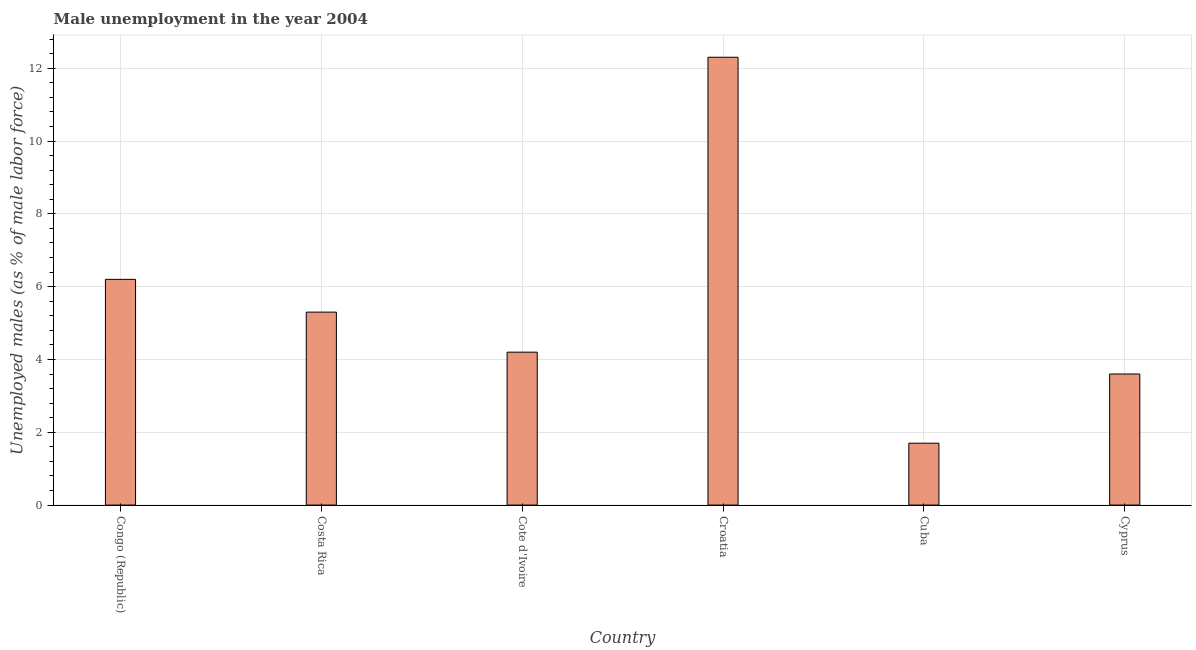Does the graph contain any zero values?
Your answer should be compact. No. Does the graph contain grids?
Provide a succinct answer. Yes. What is the title of the graph?
Offer a very short reply. Male unemployment in the year 2004. What is the label or title of the X-axis?
Give a very brief answer. Country. What is the label or title of the Y-axis?
Keep it short and to the point. Unemployed males (as % of male labor force). What is the unemployed males population in Congo (Republic)?
Your response must be concise. 6.2. Across all countries, what is the maximum unemployed males population?
Your answer should be very brief. 12.3. Across all countries, what is the minimum unemployed males population?
Offer a terse response. 1.7. In which country was the unemployed males population maximum?
Offer a very short reply. Croatia. In which country was the unemployed males population minimum?
Offer a terse response. Cuba. What is the sum of the unemployed males population?
Offer a terse response. 33.3. What is the difference between the unemployed males population in Cote d'Ivoire and Cyprus?
Provide a succinct answer. 0.6. What is the average unemployed males population per country?
Your response must be concise. 5.55. What is the median unemployed males population?
Offer a terse response. 4.75. What is the ratio of the unemployed males population in Cote d'Ivoire to that in Cuba?
Provide a succinct answer. 2.47. Is the unemployed males population in Cuba less than that in Cyprus?
Provide a short and direct response. Yes. Is the sum of the unemployed males population in Costa Rica and Croatia greater than the maximum unemployed males population across all countries?
Give a very brief answer. Yes. What is the difference between the highest and the lowest unemployed males population?
Make the answer very short. 10.6. In how many countries, is the unemployed males population greater than the average unemployed males population taken over all countries?
Make the answer very short. 2. Are all the bars in the graph horizontal?
Provide a succinct answer. No. How many countries are there in the graph?
Offer a very short reply. 6. What is the difference between two consecutive major ticks on the Y-axis?
Offer a very short reply. 2. Are the values on the major ticks of Y-axis written in scientific E-notation?
Keep it short and to the point. No. What is the Unemployed males (as % of male labor force) in Congo (Republic)?
Your answer should be very brief. 6.2. What is the Unemployed males (as % of male labor force) in Costa Rica?
Your response must be concise. 5.3. What is the Unemployed males (as % of male labor force) of Cote d'Ivoire?
Offer a terse response. 4.2. What is the Unemployed males (as % of male labor force) of Croatia?
Provide a short and direct response. 12.3. What is the Unemployed males (as % of male labor force) of Cuba?
Your answer should be very brief. 1.7. What is the Unemployed males (as % of male labor force) in Cyprus?
Make the answer very short. 3.6. What is the difference between the Unemployed males (as % of male labor force) in Congo (Republic) and Costa Rica?
Provide a succinct answer. 0.9. What is the difference between the Unemployed males (as % of male labor force) in Congo (Republic) and Cote d'Ivoire?
Provide a short and direct response. 2. What is the difference between the Unemployed males (as % of male labor force) in Costa Rica and Cyprus?
Your response must be concise. 1.7. What is the difference between the Unemployed males (as % of male labor force) in Cote d'Ivoire and Croatia?
Offer a terse response. -8.1. What is the difference between the Unemployed males (as % of male labor force) in Croatia and Cuba?
Provide a succinct answer. 10.6. What is the difference between the Unemployed males (as % of male labor force) in Croatia and Cyprus?
Your answer should be compact. 8.7. What is the difference between the Unemployed males (as % of male labor force) in Cuba and Cyprus?
Offer a very short reply. -1.9. What is the ratio of the Unemployed males (as % of male labor force) in Congo (Republic) to that in Costa Rica?
Your answer should be compact. 1.17. What is the ratio of the Unemployed males (as % of male labor force) in Congo (Republic) to that in Cote d'Ivoire?
Make the answer very short. 1.48. What is the ratio of the Unemployed males (as % of male labor force) in Congo (Republic) to that in Croatia?
Offer a very short reply. 0.5. What is the ratio of the Unemployed males (as % of male labor force) in Congo (Republic) to that in Cuba?
Ensure brevity in your answer.  3.65. What is the ratio of the Unemployed males (as % of male labor force) in Congo (Republic) to that in Cyprus?
Your answer should be very brief. 1.72. What is the ratio of the Unemployed males (as % of male labor force) in Costa Rica to that in Cote d'Ivoire?
Provide a succinct answer. 1.26. What is the ratio of the Unemployed males (as % of male labor force) in Costa Rica to that in Croatia?
Your answer should be very brief. 0.43. What is the ratio of the Unemployed males (as % of male labor force) in Costa Rica to that in Cuba?
Make the answer very short. 3.12. What is the ratio of the Unemployed males (as % of male labor force) in Costa Rica to that in Cyprus?
Offer a terse response. 1.47. What is the ratio of the Unemployed males (as % of male labor force) in Cote d'Ivoire to that in Croatia?
Make the answer very short. 0.34. What is the ratio of the Unemployed males (as % of male labor force) in Cote d'Ivoire to that in Cuba?
Keep it short and to the point. 2.47. What is the ratio of the Unemployed males (as % of male labor force) in Cote d'Ivoire to that in Cyprus?
Your response must be concise. 1.17. What is the ratio of the Unemployed males (as % of male labor force) in Croatia to that in Cuba?
Offer a very short reply. 7.24. What is the ratio of the Unemployed males (as % of male labor force) in Croatia to that in Cyprus?
Your answer should be compact. 3.42. What is the ratio of the Unemployed males (as % of male labor force) in Cuba to that in Cyprus?
Provide a short and direct response. 0.47. 